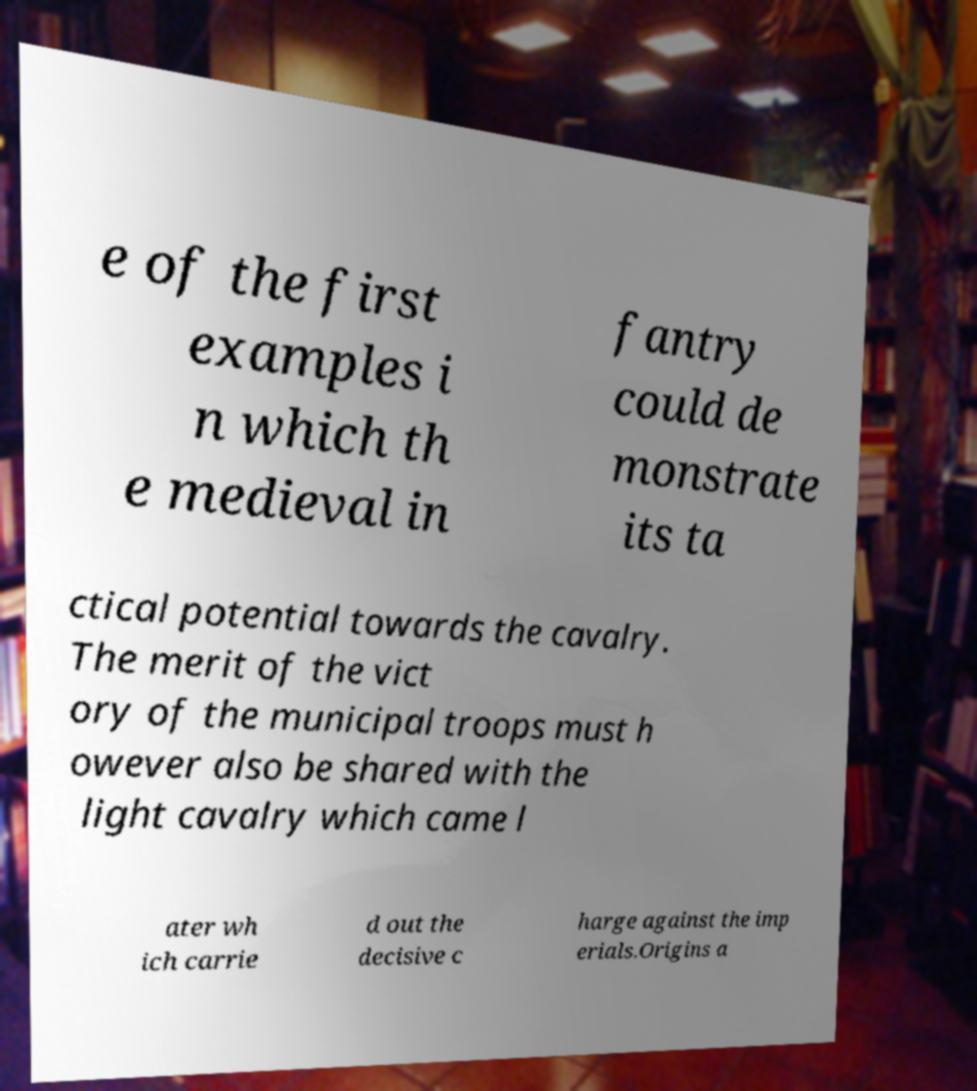Please identify and transcribe the text found in this image. e of the first examples i n which th e medieval in fantry could de monstrate its ta ctical potential towards the cavalry. The merit of the vict ory of the municipal troops must h owever also be shared with the light cavalry which came l ater wh ich carrie d out the decisive c harge against the imp erials.Origins a 